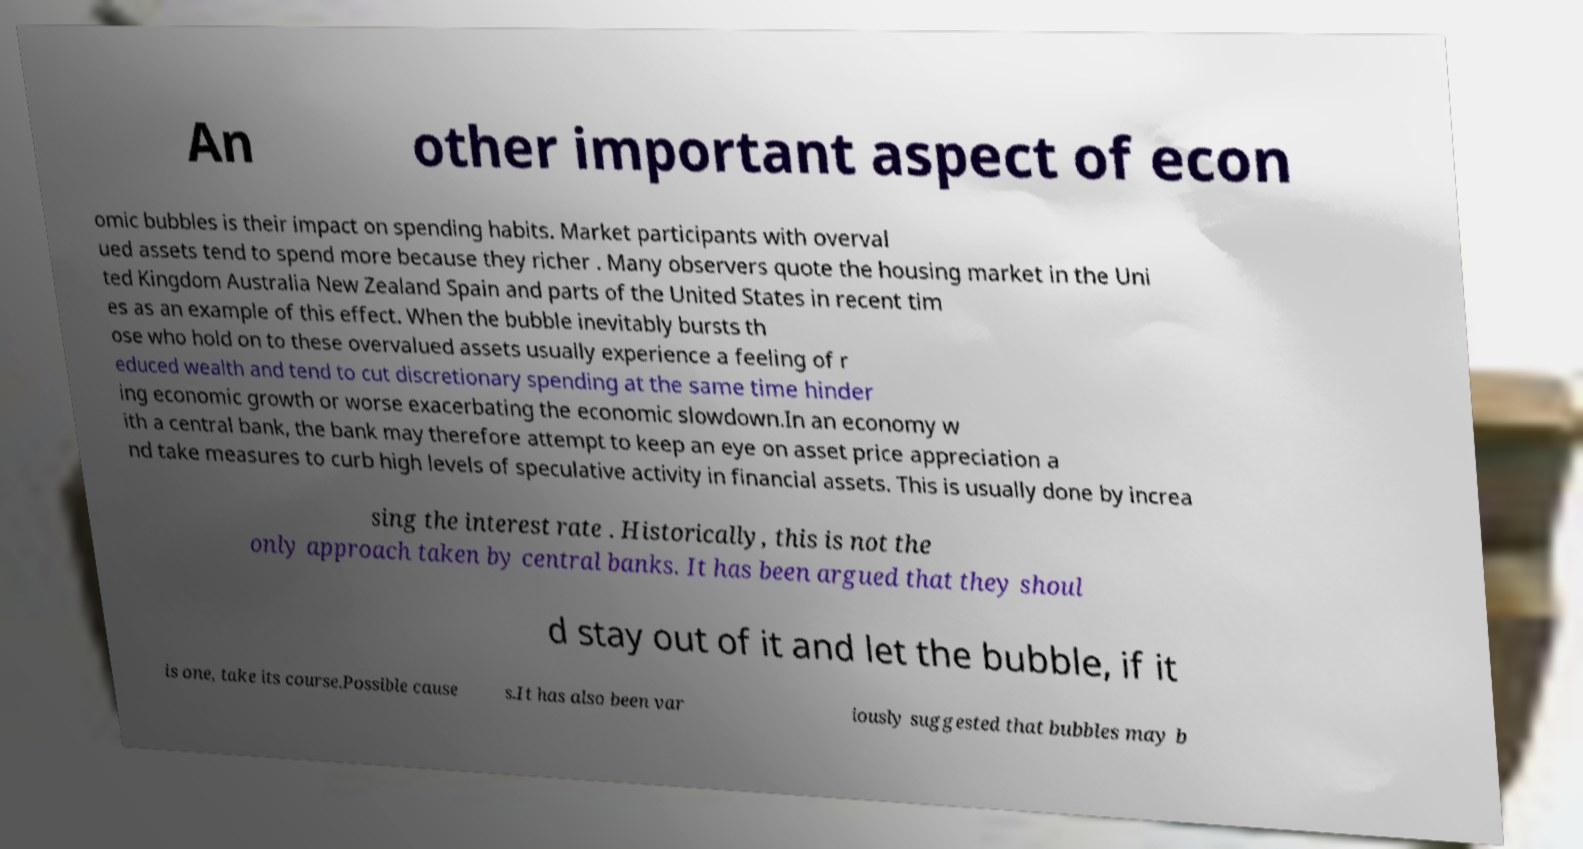For documentation purposes, I need the text within this image transcribed. Could you provide that? An other important aspect of econ omic bubbles is their impact on spending habits. Market participants with overval ued assets tend to spend more because they richer . Many observers quote the housing market in the Uni ted Kingdom Australia New Zealand Spain and parts of the United States in recent tim es as an example of this effect. When the bubble inevitably bursts th ose who hold on to these overvalued assets usually experience a feeling of r educed wealth and tend to cut discretionary spending at the same time hinder ing economic growth or worse exacerbating the economic slowdown.In an economy w ith a central bank, the bank may therefore attempt to keep an eye on asset price appreciation a nd take measures to curb high levels of speculative activity in financial assets. This is usually done by increa sing the interest rate . Historically, this is not the only approach taken by central banks. It has been argued that they shoul d stay out of it and let the bubble, if it is one, take its course.Possible cause s.It has also been var iously suggested that bubbles may b 